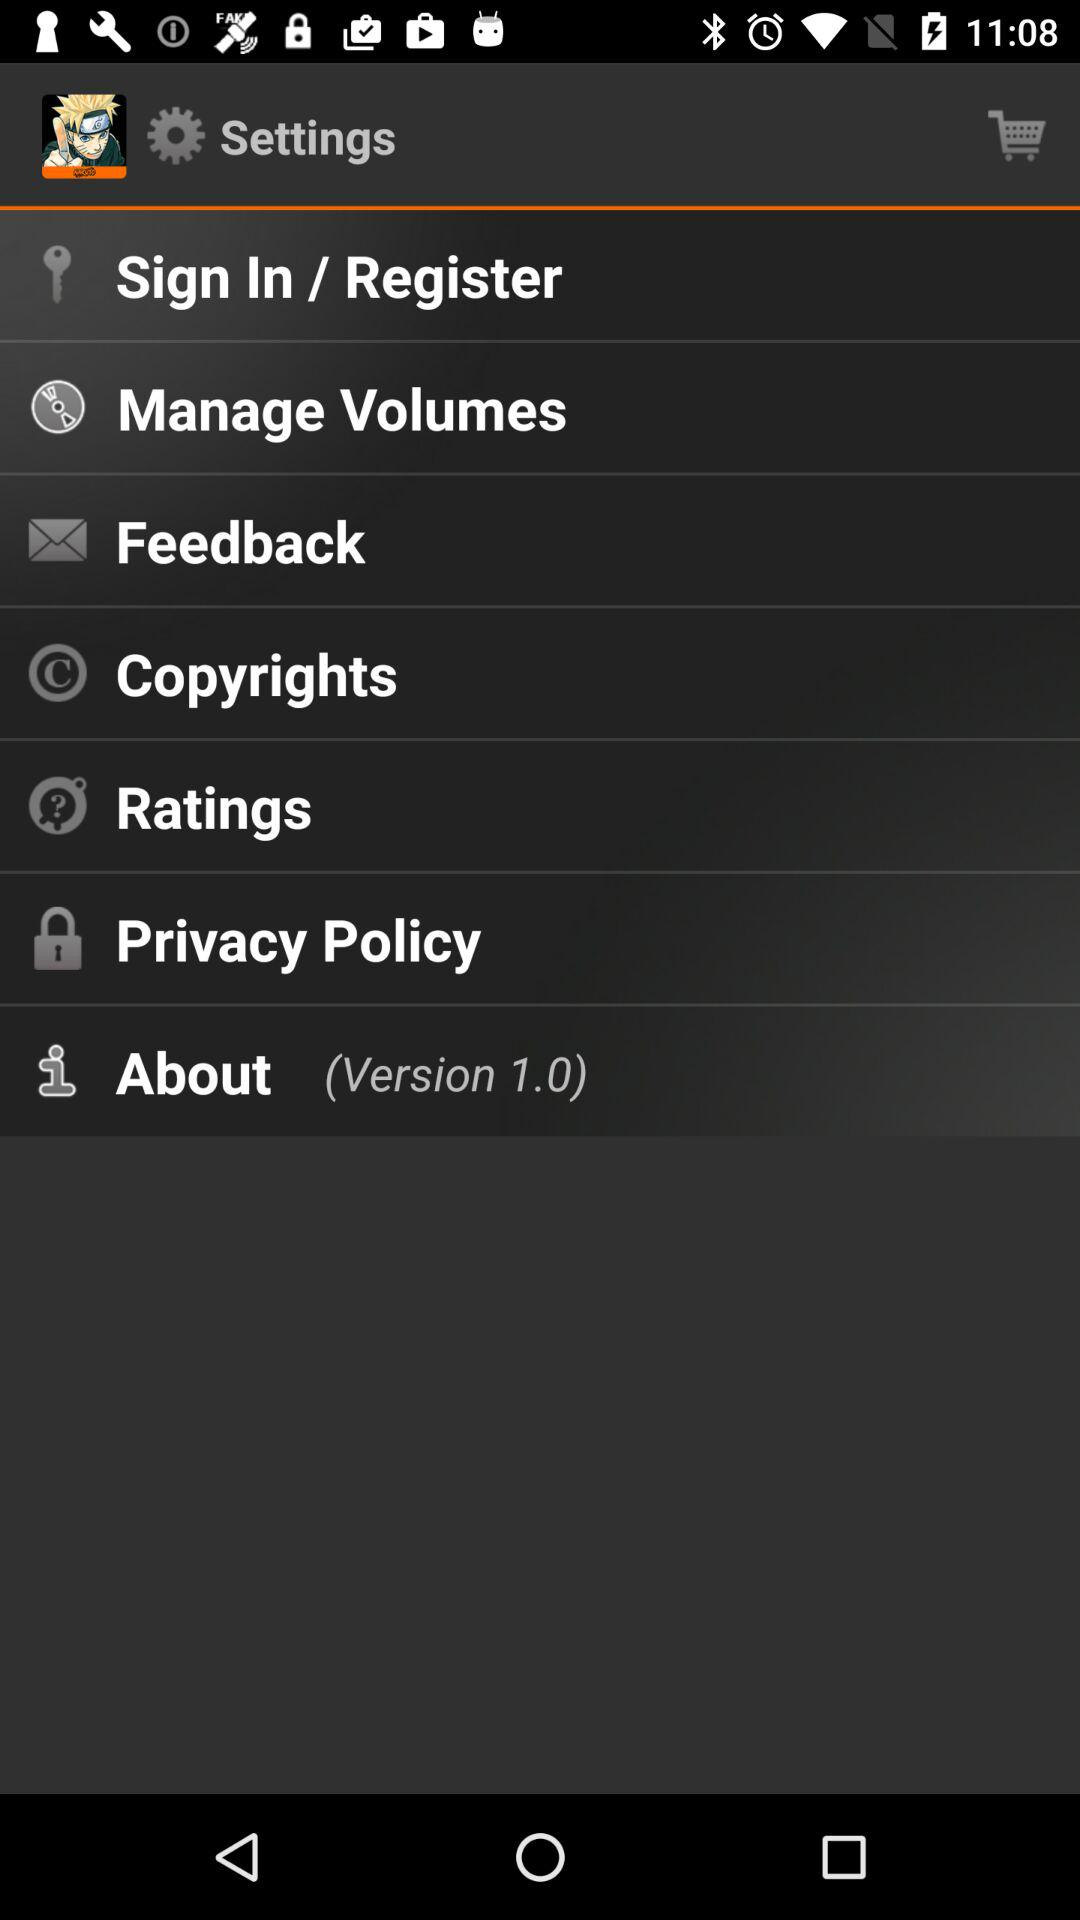Which version is used? The used version is 1.0. 